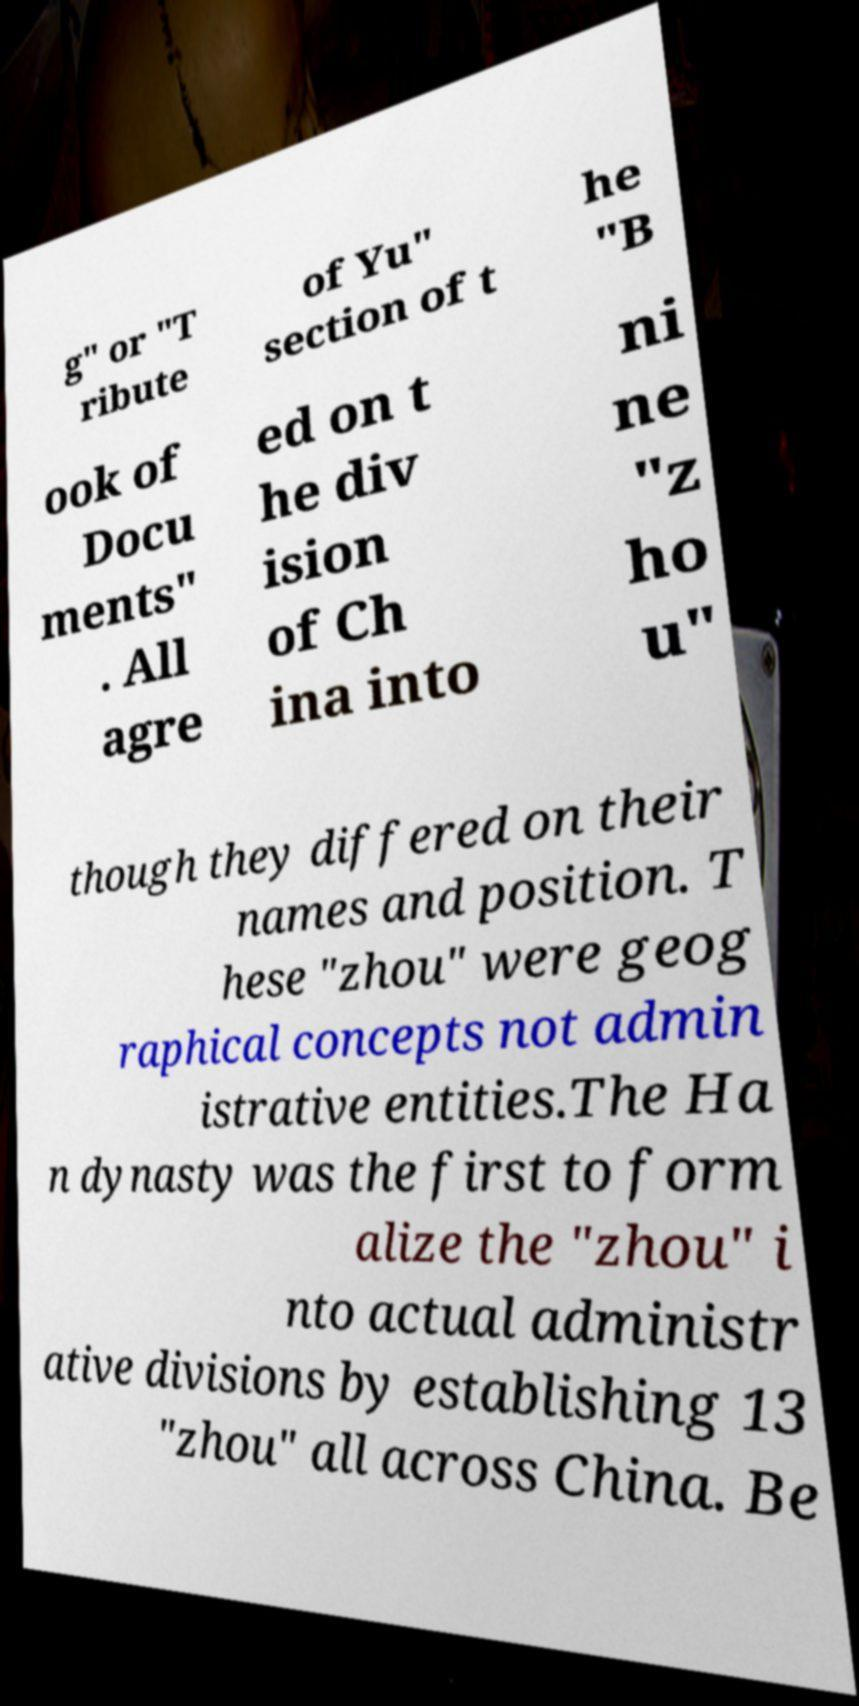Can you accurately transcribe the text from the provided image for me? g" or "T ribute of Yu" section of t he "B ook of Docu ments" . All agre ed on t he div ision of Ch ina into ni ne "z ho u" though they differed on their names and position. T hese "zhou" were geog raphical concepts not admin istrative entities.The Ha n dynasty was the first to form alize the "zhou" i nto actual administr ative divisions by establishing 13 "zhou" all across China. Be 